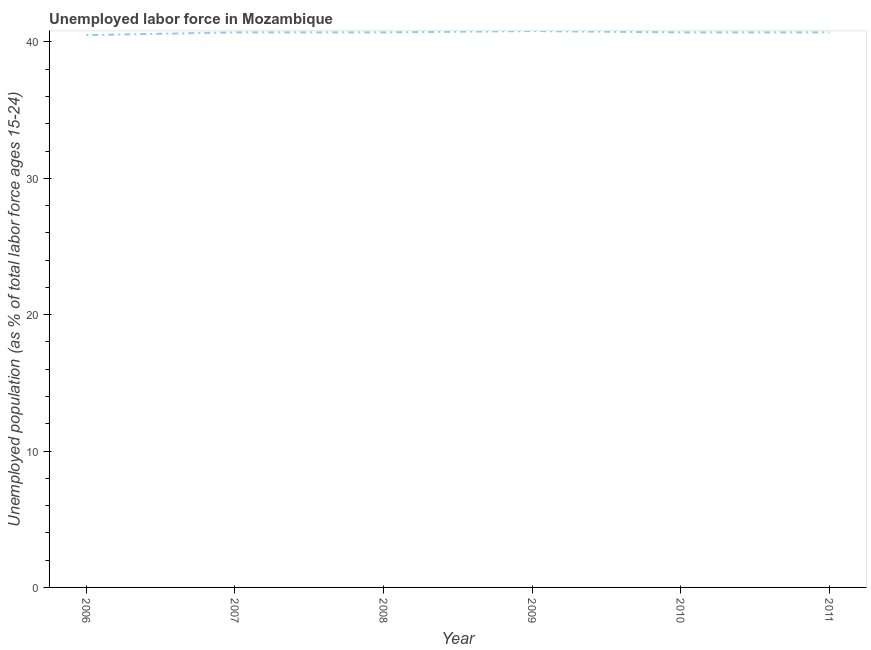What is the total unemployed youth population in 2009?
Provide a succinct answer. 40.8. Across all years, what is the maximum total unemployed youth population?
Give a very brief answer. 40.8. Across all years, what is the minimum total unemployed youth population?
Your answer should be very brief. 40.5. In which year was the total unemployed youth population minimum?
Provide a succinct answer. 2006. What is the sum of the total unemployed youth population?
Provide a succinct answer. 244.1. What is the average total unemployed youth population per year?
Your answer should be compact. 40.68. What is the median total unemployed youth population?
Provide a succinct answer. 40.7. Do a majority of the years between 2006 and 2008 (inclusive) have total unemployed youth population greater than 6 %?
Make the answer very short. Yes. What is the ratio of the total unemployed youth population in 2006 to that in 2010?
Your answer should be compact. 1. Is the total unemployed youth population in 2007 less than that in 2011?
Provide a short and direct response. No. What is the difference between the highest and the second highest total unemployed youth population?
Offer a very short reply. 0.1. What is the difference between the highest and the lowest total unemployed youth population?
Ensure brevity in your answer.  0.3. In how many years, is the total unemployed youth population greater than the average total unemployed youth population taken over all years?
Provide a succinct answer. 5. Does the total unemployed youth population monotonically increase over the years?
Keep it short and to the point. No. How many lines are there?
Make the answer very short. 1. How many years are there in the graph?
Provide a short and direct response. 6. What is the difference between two consecutive major ticks on the Y-axis?
Offer a very short reply. 10. What is the title of the graph?
Ensure brevity in your answer.  Unemployed labor force in Mozambique. What is the label or title of the Y-axis?
Provide a short and direct response. Unemployed population (as % of total labor force ages 15-24). What is the Unemployed population (as % of total labor force ages 15-24) in 2006?
Your answer should be very brief. 40.5. What is the Unemployed population (as % of total labor force ages 15-24) in 2007?
Offer a very short reply. 40.7. What is the Unemployed population (as % of total labor force ages 15-24) of 2008?
Offer a very short reply. 40.7. What is the Unemployed population (as % of total labor force ages 15-24) in 2009?
Provide a succinct answer. 40.8. What is the Unemployed population (as % of total labor force ages 15-24) of 2010?
Keep it short and to the point. 40.7. What is the Unemployed population (as % of total labor force ages 15-24) in 2011?
Your answer should be very brief. 40.7. What is the difference between the Unemployed population (as % of total labor force ages 15-24) in 2006 and 2010?
Keep it short and to the point. -0.2. What is the difference between the Unemployed population (as % of total labor force ages 15-24) in 2006 and 2011?
Your response must be concise. -0.2. What is the difference between the Unemployed population (as % of total labor force ages 15-24) in 2007 and 2008?
Offer a terse response. 0. What is the difference between the Unemployed population (as % of total labor force ages 15-24) in 2007 and 2011?
Ensure brevity in your answer.  0. What is the difference between the Unemployed population (as % of total labor force ages 15-24) in 2008 and 2009?
Keep it short and to the point. -0.1. What is the difference between the Unemployed population (as % of total labor force ages 15-24) in 2008 and 2010?
Keep it short and to the point. 0. What is the difference between the Unemployed population (as % of total labor force ages 15-24) in 2008 and 2011?
Your answer should be very brief. 0. What is the difference between the Unemployed population (as % of total labor force ages 15-24) in 2009 and 2011?
Offer a very short reply. 0.1. What is the difference between the Unemployed population (as % of total labor force ages 15-24) in 2010 and 2011?
Your answer should be compact. 0. What is the ratio of the Unemployed population (as % of total labor force ages 15-24) in 2006 to that in 2007?
Your answer should be compact. 0.99. What is the ratio of the Unemployed population (as % of total labor force ages 15-24) in 2006 to that in 2011?
Your answer should be compact. 0.99. What is the ratio of the Unemployed population (as % of total labor force ages 15-24) in 2007 to that in 2009?
Your answer should be very brief. 1. What is the ratio of the Unemployed population (as % of total labor force ages 15-24) in 2007 to that in 2010?
Make the answer very short. 1. What is the ratio of the Unemployed population (as % of total labor force ages 15-24) in 2008 to that in 2010?
Provide a short and direct response. 1. What is the ratio of the Unemployed population (as % of total labor force ages 15-24) in 2009 to that in 2011?
Your answer should be very brief. 1. What is the ratio of the Unemployed population (as % of total labor force ages 15-24) in 2010 to that in 2011?
Provide a succinct answer. 1. 